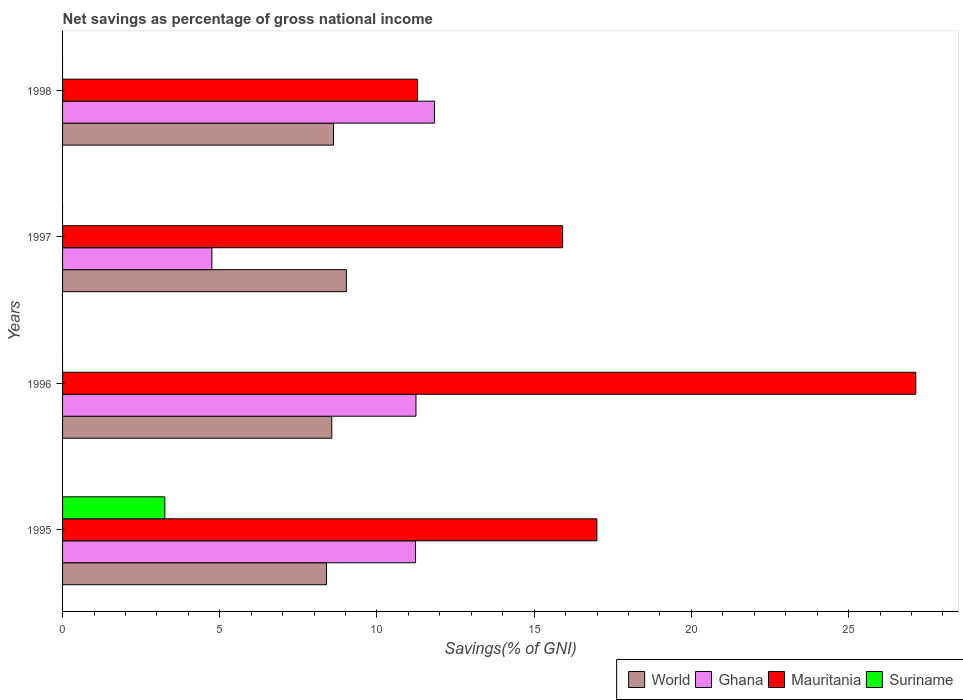Are the number of bars per tick equal to the number of legend labels?
Ensure brevity in your answer.  No. Are the number of bars on each tick of the Y-axis equal?
Keep it short and to the point. No. How many bars are there on the 2nd tick from the top?
Your answer should be very brief. 3. What is the total savings in World in 1997?
Your answer should be very brief. 9.03. Across all years, what is the maximum total savings in Ghana?
Keep it short and to the point. 11.83. In which year was the total savings in World maximum?
Provide a short and direct response. 1997. What is the total total savings in Mauritania in the graph?
Offer a very short reply. 71.32. What is the difference between the total savings in Mauritania in 1996 and that in 1997?
Offer a very short reply. 11.23. What is the difference between the total savings in World in 1995 and the total savings in Mauritania in 1997?
Your response must be concise. -7.51. What is the average total savings in Suriname per year?
Your answer should be compact. 0.81. In the year 1997, what is the difference between the total savings in Mauritania and total savings in Ghana?
Provide a succinct answer. 11.16. In how many years, is the total savings in Mauritania greater than 12 %?
Provide a short and direct response. 3. What is the ratio of the total savings in World in 1995 to that in 1998?
Keep it short and to the point. 0.97. Is the difference between the total savings in Mauritania in 1995 and 1996 greater than the difference between the total savings in Ghana in 1995 and 1996?
Your response must be concise. No. What is the difference between the highest and the second highest total savings in World?
Your answer should be very brief. 0.41. What is the difference between the highest and the lowest total savings in Suriname?
Your response must be concise. 3.25. Is it the case that in every year, the sum of the total savings in Mauritania and total savings in World is greater than the sum of total savings in Ghana and total savings in Suriname?
Ensure brevity in your answer.  No. Is it the case that in every year, the sum of the total savings in Ghana and total savings in Mauritania is greater than the total savings in World?
Make the answer very short. Yes. How many years are there in the graph?
Provide a short and direct response. 4. Does the graph contain any zero values?
Give a very brief answer. Yes. What is the title of the graph?
Offer a very short reply. Net savings as percentage of gross national income. Does "Italy" appear as one of the legend labels in the graph?
Keep it short and to the point. No. What is the label or title of the X-axis?
Your answer should be compact. Savings(% of GNI). What is the Savings(% of GNI) in World in 1995?
Your answer should be compact. 8.39. What is the Savings(% of GNI) in Ghana in 1995?
Offer a very short reply. 11.22. What is the Savings(% of GNI) in Mauritania in 1995?
Provide a succinct answer. 16.99. What is the Savings(% of GNI) of Suriname in 1995?
Provide a short and direct response. 3.25. What is the Savings(% of GNI) in World in 1996?
Provide a short and direct response. 8.56. What is the Savings(% of GNI) of Ghana in 1996?
Your response must be concise. 11.24. What is the Savings(% of GNI) of Mauritania in 1996?
Ensure brevity in your answer.  27.14. What is the Savings(% of GNI) of Suriname in 1996?
Ensure brevity in your answer.  0. What is the Savings(% of GNI) of World in 1997?
Keep it short and to the point. 9.03. What is the Savings(% of GNI) of Ghana in 1997?
Offer a terse response. 4.75. What is the Savings(% of GNI) of Mauritania in 1997?
Your response must be concise. 15.9. What is the Savings(% of GNI) of Suriname in 1997?
Offer a terse response. 0. What is the Savings(% of GNI) in World in 1998?
Give a very brief answer. 8.62. What is the Savings(% of GNI) of Ghana in 1998?
Make the answer very short. 11.83. What is the Savings(% of GNI) in Mauritania in 1998?
Offer a terse response. 11.29. What is the Savings(% of GNI) of Suriname in 1998?
Your answer should be compact. 0. Across all years, what is the maximum Savings(% of GNI) in World?
Your response must be concise. 9.03. Across all years, what is the maximum Savings(% of GNI) in Ghana?
Offer a very short reply. 11.83. Across all years, what is the maximum Savings(% of GNI) in Mauritania?
Your answer should be very brief. 27.14. Across all years, what is the maximum Savings(% of GNI) in Suriname?
Keep it short and to the point. 3.25. Across all years, what is the minimum Savings(% of GNI) in World?
Make the answer very short. 8.39. Across all years, what is the minimum Savings(% of GNI) in Ghana?
Provide a succinct answer. 4.75. Across all years, what is the minimum Savings(% of GNI) in Mauritania?
Make the answer very short. 11.29. Across all years, what is the minimum Savings(% of GNI) in Suriname?
Keep it short and to the point. 0. What is the total Savings(% of GNI) of World in the graph?
Make the answer very short. 34.6. What is the total Savings(% of GNI) of Ghana in the graph?
Provide a succinct answer. 39.04. What is the total Savings(% of GNI) in Mauritania in the graph?
Give a very brief answer. 71.32. What is the total Savings(% of GNI) of Suriname in the graph?
Ensure brevity in your answer.  3.25. What is the difference between the Savings(% of GNI) in World in 1995 and that in 1996?
Provide a short and direct response. -0.17. What is the difference between the Savings(% of GNI) in Ghana in 1995 and that in 1996?
Keep it short and to the point. -0.02. What is the difference between the Savings(% of GNI) in Mauritania in 1995 and that in 1996?
Provide a short and direct response. -10.14. What is the difference between the Savings(% of GNI) in World in 1995 and that in 1997?
Provide a short and direct response. -0.63. What is the difference between the Savings(% of GNI) in Ghana in 1995 and that in 1997?
Offer a terse response. 6.48. What is the difference between the Savings(% of GNI) in Mauritania in 1995 and that in 1997?
Offer a very short reply. 1.09. What is the difference between the Savings(% of GNI) of World in 1995 and that in 1998?
Your answer should be compact. -0.23. What is the difference between the Savings(% of GNI) of Ghana in 1995 and that in 1998?
Your response must be concise. -0.6. What is the difference between the Savings(% of GNI) of Mauritania in 1995 and that in 1998?
Your answer should be very brief. 5.71. What is the difference between the Savings(% of GNI) of World in 1996 and that in 1997?
Make the answer very short. -0.46. What is the difference between the Savings(% of GNI) of Ghana in 1996 and that in 1997?
Offer a very short reply. 6.49. What is the difference between the Savings(% of GNI) of Mauritania in 1996 and that in 1997?
Offer a terse response. 11.23. What is the difference between the Savings(% of GNI) in World in 1996 and that in 1998?
Your answer should be compact. -0.06. What is the difference between the Savings(% of GNI) in Ghana in 1996 and that in 1998?
Your answer should be compact. -0.59. What is the difference between the Savings(% of GNI) of Mauritania in 1996 and that in 1998?
Offer a very short reply. 15.85. What is the difference between the Savings(% of GNI) of World in 1997 and that in 1998?
Give a very brief answer. 0.41. What is the difference between the Savings(% of GNI) of Ghana in 1997 and that in 1998?
Provide a short and direct response. -7.08. What is the difference between the Savings(% of GNI) in Mauritania in 1997 and that in 1998?
Make the answer very short. 4.62. What is the difference between the Savings(% of GNI) in World in 1995 and the Savings(% of GNI) in Ghana in 1996?
Make the answer very short. -2.85. What is the difference between the Savings(% of GNI) in World in 1995 and the Savings(% of GNI) in Mauritania in 1996?
Offer a very short reply. -18.74. What is the difference between the Savings(% of GNI) in Ghana in 1995 and the Savings(% of GNI) in Mauritania in 1996?
Give a very brief answer. -15.91. What is the difference between the Savings(% of GNI) in World in 1995 and the Savings(% of GNI) in Ghana in 1997?
Offer a very short reply. 3.64. What is the difference between the Savings(% of GNI) in World in 1995 and the Savings(% of GNI) in Mauritania in 1997?
Provide a succinct answer. -7.51. What is the difference between the Savings(% of GNI) in Ghana in 1995 and the Savings(% of GNI) in Mauritania in 1997?
Offer a terse response. -4.68. What is the difference between the Savings(% of GNI) of World in 1995 and the Savings(% of GNI) of Ghana in 1998?
Your response must be concise. -3.44. What is the difference between the Savings(% of GNI) of World in 1995 and the Savings(% of GNI) of Mauritania in 1998?
Provide a succinct answer. -2.89. What is the difference between the Savings(% of GNI) in Ghana in 1995 and the Savings(% of GNI) in Mauritania in 1998?
Provide a succinct answer. -0.06. What is the difference between the Savings(% of GNI) in World in 1996 and the Savings(% of GNI) in Ghana in 1997?
Your answer should be very brief. 3.81. What is the difference between the Savings(% of GNI) of World in 1996 and the Savings(% of GNI) of Mauritania in 1997?
Your answer should be very brief. -7.34. What is the difference between the Savings(% of GNI) of Ghana in 1996 and the Savings(% of GNI) of Mauritania in 1997?
Your answer should be compact. -4.67. What is the difference between the Savings(% of GNI) in World in 1996 and the Savings(% of GNI) in Ghana in 1998?
Offer a very short reply. -3.27. What is the difference between the Savings(% of GNI) of World in 1996 and the Savings(% of GNI) of Mauritania in 1998?
Your response must be concise. -2.73. What is the difference between the Savings(% of GNI) of Ghana in 1996 and the Savings(% of GNI) of Mauritania in 1998?
Your answer should be very brief. -0.05. What is the difference between the Savings(% of GNI) of World in 1997 and the Savings(% of GNI) of Ghana in 1998?
Give a very brief answer. -2.8. What is the difference between the Savings(% of GNI) of World in 1997 and the Savings(% of GNI) of Mauritania in 1998?
Offer a terse response. -2.26. What is the difference between the Savings(% of GNI) of Ghana in 1997 and the Savings(% of GNI) of Mauritania in 1998?
Your answer should be very brief. -6.54. What is the average Savings(% of GNI) in World per year?
Keep it short and to the point. 8.65. What is the average Savings(% of GNI) in Ghana per year?
Make the answer very short. 9.76. What is the average Savings(% of GNI) of Mauritania per year?
Ensure brevity in your answer.  17.83. What is the average Savings(% of GNI) in Suriname per year?
Offer a very short reply. 0.81. In the year 1995, what is the difference between the Savings(% of GNI) of World and Savings(% of GNI) of Ghana?
Your answer should be very brief. -2.83. In the year 1995, what is the difference between the Savings(% of GNI) in World and Savings(% of GNI) in Mauritania?
Your answer should be compact. -8.6. In the year 1995, what is the difference between the Savings(% of GNI) of World and Savings(% of GNI) of Suriname?
Offer a very short reply. 5.14. In the year 1995, what is the difference between the Savings(% of GNI) in Ghana and Savings(% of GNI) in Mauritania?
Your response must be concise. -5.77. In the year 1995, what is the difference between the Savings(% of GNI) in Ghana and Savings(% of GNI) in Suriname?
Make the answer very short. 7.97. In the year 1995, what is the difference between the Savings(% of GNI) in Mauritania and Savings(% of GNI) in Suriname?
Keep it short and to the point. 13.74. In the year 1996, what is the difference between the Savings(% of GNI) in World and Savings(% of GNI) in Ghana?
Your answer should be very brief. -2.68. In the year 1996, what is the difference between the Savings(% of GNI) in World and Savings(% of GNI) in Mauritania?
Your answer should be very brief. -18.58. In the year 1996, what is the difference between the Savings(% of GNI) of Ghana and Savings(% of GNI) of Mauritania?
Your answer should be very brief. -15.9. In the year 1997, what is the difference between the Savings(% of GNI) of World and Savings(% of GNI) of Ghana?
Your response must be concise. 4.28. In the year 1997, what is the difference between the Savings(% of GNI) of World and Savings(% of GNI) of Mauritania?
Make the answer very short. -6.88. In the year 1997, what is the difference between the Savings(% of GNI) in Ghana and Savings(% of GNI) in Mauritania?
Provide a short and direct response. -11.16. In the year 1998, what is the difference between the Savings(% of GNI) of World and Savings(% of GNI) of Ghana?
Make the answer very short. -3.21. In the year 1998, what is the difference between the Savings(% of GNI) in World and Savings(% of GNI) in Mauritania?
Your answer should be very brief. -2.67. In the year 1998, what is the difference between the Savings(% of GNI) of Ghana and Savings(% of GNI) of Mauritania?
Provide a short and direct response. 0.54. What is the ratio of the Savings(% of GNI) in World in 1995 to that in 1996?
Make the answer very short. 0.98. What is the ratio of the Savings(% of GNI) of Ghana in 1995 to that in 1996?
Make the answer very short. 1. What is the ratio of the Savings(% of GNI) of Mauritania in 1995 to that in 1996?
Provide a short and direct response. 0.63. What is the ratio of the Savings(% of GNI) in World in 1995 to that in 1997?
Provide a succinct answer. 0.93. What is the ratio of the Savings(% of GNI) in Ghana in 1995 to that in 1997?
Your response must be concise. 2.36. What is the ratio of the Savings(% of GNI) of Mauritania in 1995 to that in 1997?
Your answer should be compact. 1.07. What is the ratio of the Savings(% of GNI) in World in 1995 to that in 1998?
Provide a succinct answer. 0.97. What is the ratio of the Savings(% of GNI) of Ghana in 1995 to that in 1998?
Your response must be concise. 0.95. What is the ratio of the Savings(% of GNI) in Mauritania in 1995 to that in 1998?
Offer a very short reply. 1.51. What is the ratio of the Savings(% of GNI) in World in 1996 to that in 1997?
Your response must be concise. 0.95. What is the ratio of the Savings(% of GNI) in Ghana in 1996 to that in 1997?
Provide a short and direct response. 2.37. What is the ratio of the Savings(% of GNI) of Mauritania in 1996 to that in 1997?
Provide a short and direct response. 1.71. What is the ratio of the Savings(% of GNI) of World in 1996 to that in 1998?
Give a very brief answer. 0.99. What is the ratio of the Savings(% of GNI) in Ghana in 1996 to that in 1998?
Offer a very short reply. 0.95. What is the ratio of the Savings(% of GNI) of Mauritania in 1996 to that in 1998?
Keep it short and to the point. 2.4. What is the ratio of the Savings(% of GNI) of World in 1997 to that in 1998?
Provide a short and direct response. 1.05. What is the ratio of the Savings(% of GNI) of Ghana in 1997 to that in 1998?
Offer a very short reply. 0.4. What is the ratio of the Savings(% of GNI) of Mauritania in 1997 to that in 1998?
Your response must be concise. 1.41. What is the difference between the highest and the second highest Savings(% of GNI) in World?
Your answer should be very brief. 0.41. What is the difference between the highest and the second highest Savings(% of GNI) in Ghana?
Your answer should be compact. 0.59. What is the difference between the highest and the second highest Savings(% of GNI) of Mauritania?
Your response must be concise. 10.14. What is the difference between the highest and the lowest Savings(% of GNI) of World?
Your answer should be very brief. 0.63. What is the difference between the highest and the lowest Savings(% of GNI) in Ghana?
Provide a succinct answer. 7.08. What is the difference between the highest and the lowest Savings(% of GNI) in Mauritania?
Provide a succinct answer. 15.85. What is the difference between the highest and the lowest Savings(% of GNI) of Suriname?
Offer a very short reply. 3.25. 